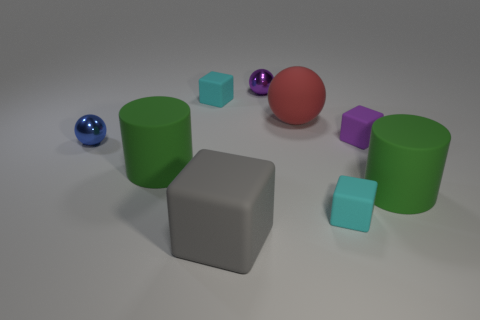Subtract all big spheres. How many spheres are left? 2 Subtract all gray blocks. How many blocks are left? 3 Subtract all green balls. How many cyan blocks are left? 2 Add 1 tiny green things. How many tiny green things exist? 1 Subtract 1 purple blocks. How many objects are left? 8 Subtract all cylinders. How many objects are left? 7 Subtract 1 balls. How many balls are left? 2 Subtract all gray spheres. Subtract all green cubes. How many spheres are left? 3 Subtract all balls. Subtract all big green cylinders. How many objects are left? 4 Add 3 big red balls. How many big red balls are left? 4 